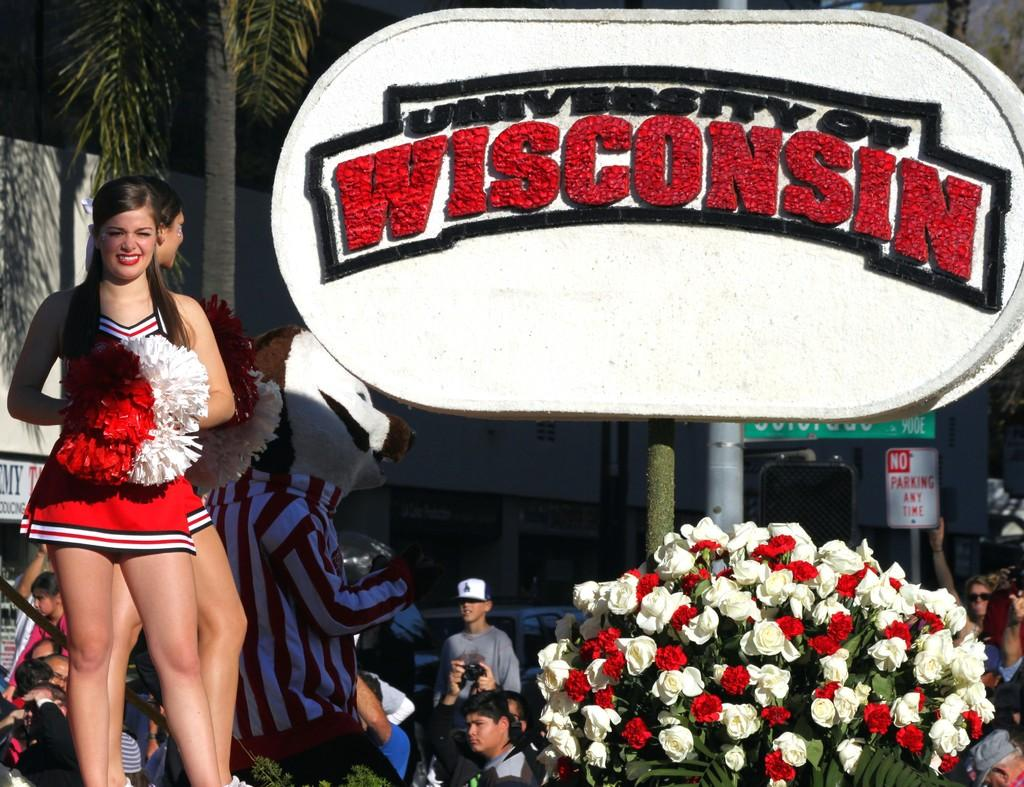<image>
Provide a brief description of the given image. Cheerleaders and a Mascot on a stage next to a large white and red flower arrangement at the University of Wisconsin. 